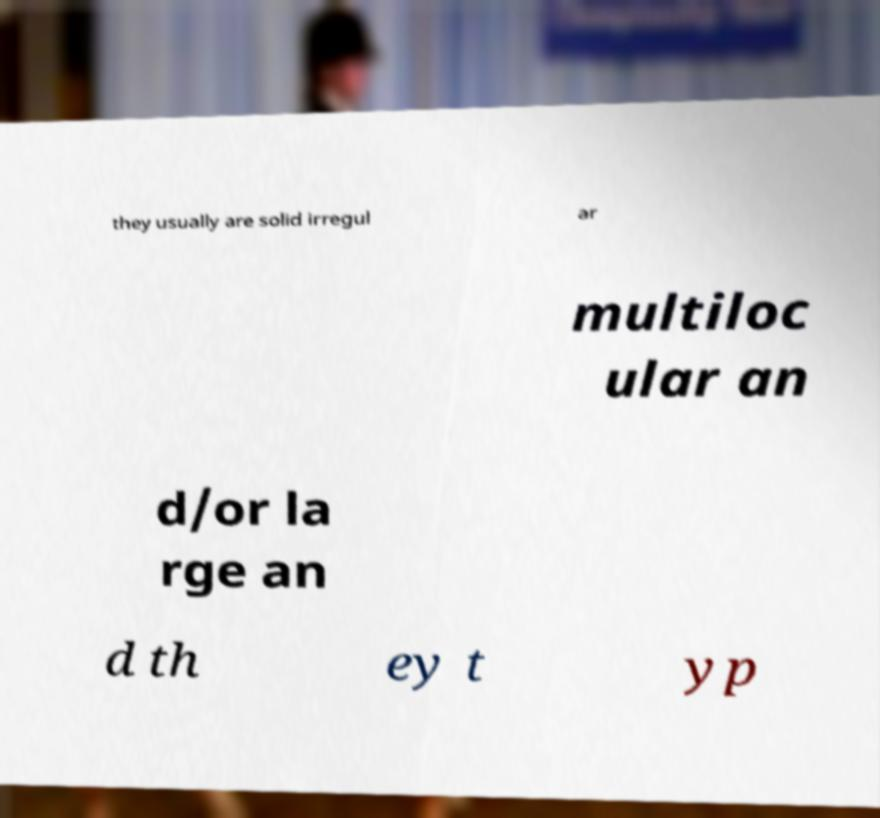Please identify and transcribe the text found in this image. they usually are solid irregul ar multiloc ular an d/or la rge an d th ey t yp 